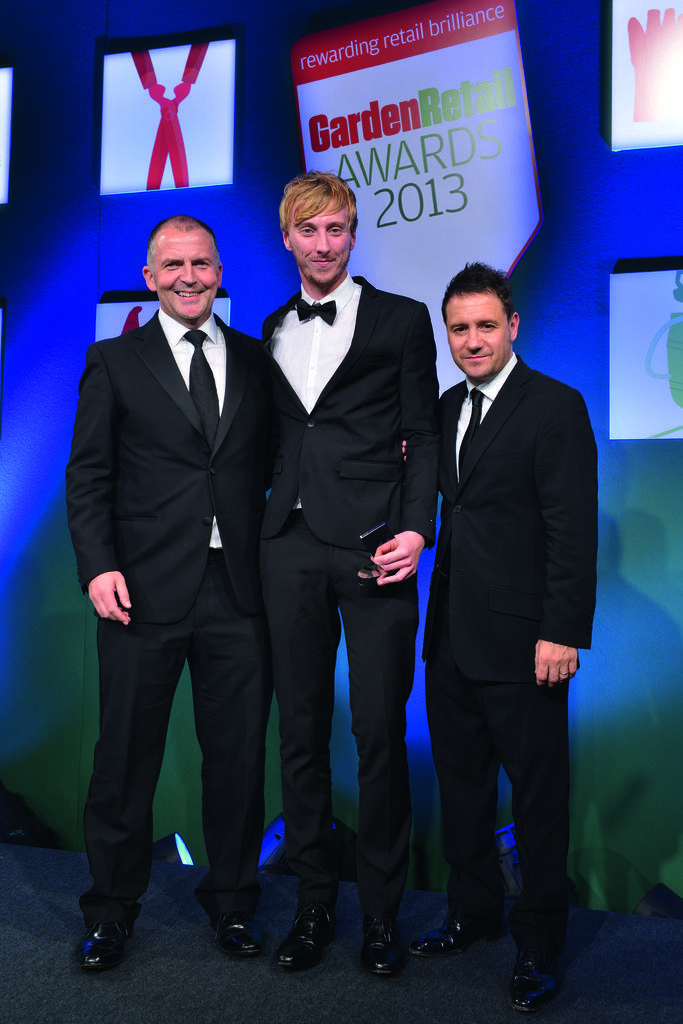In one or two sentences, can you explain what this image depicts? In this image there are persons standing and smiling. In the background there is a banner with some text written on it. 